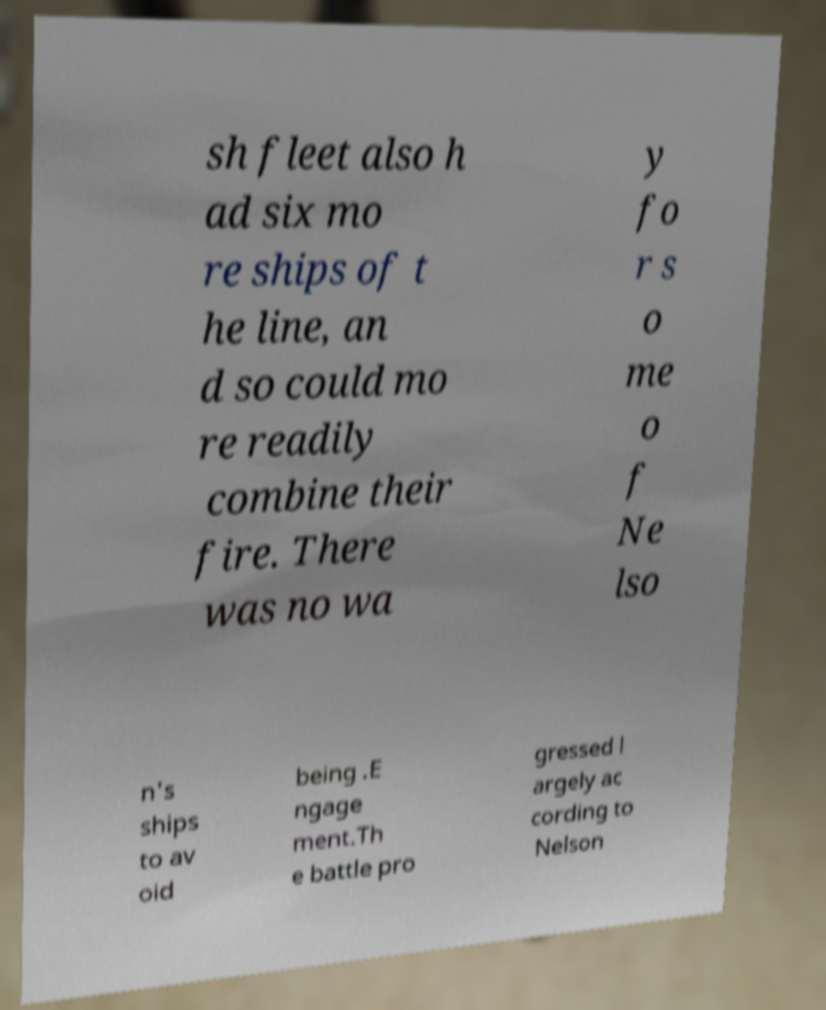For documentation purposes, I need the text within this image transcribed. Could you provide that? sh fleet also h ad six mo re ships of t he line, an d so could mo re readily combine their fire. There was no wa y fo r s o me o f Ne lso n's ships to av oid being .E ngage ment.Th e battle pro gressed l argely ac cording to Nelson 